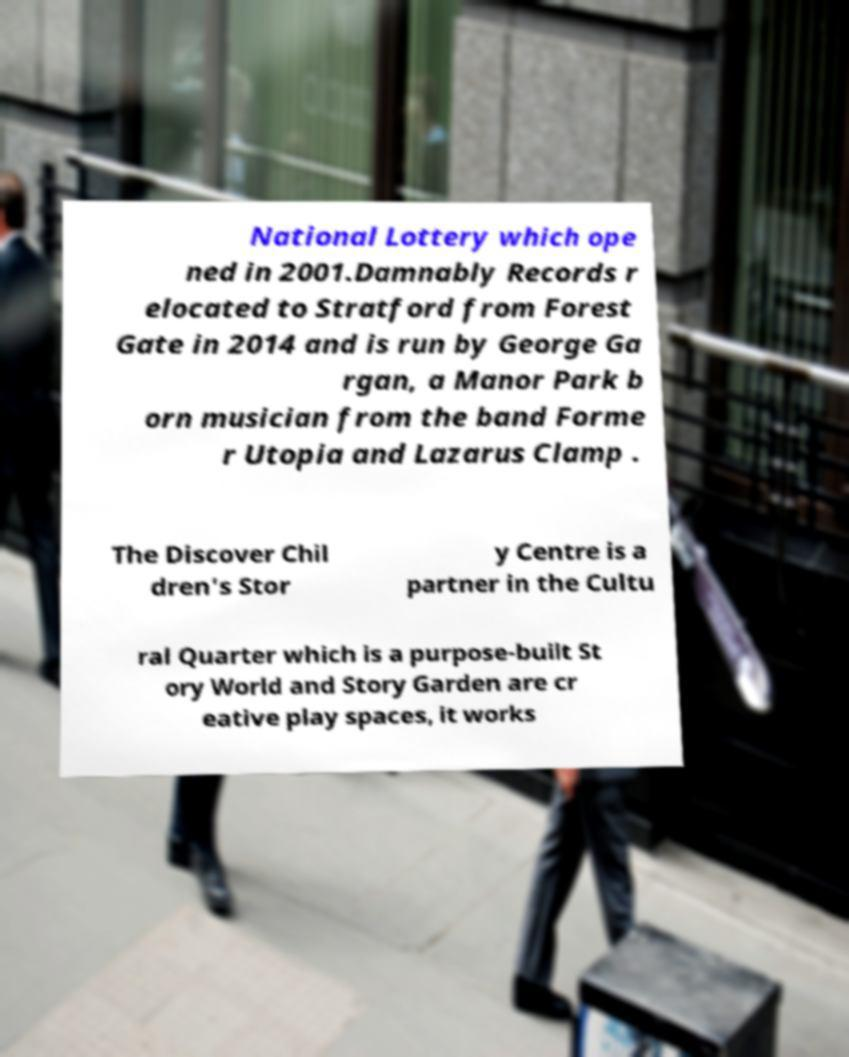Please read and relay the text visible in this image. What does it say? National Lottery which ope ned in 2001.Damnably Records r elocated to Stratford from Forest Gate in 2014 and is run by George Ga rgan, a Manor Park b orn musician from the band Forme r Utopia and Lazarus Clamp . The Discover Chil dren's Stor y Centre is a partner in the Cultu ral Quarter which is a purpose-built St ory World and Story Garden are cr eative play spaces, it works 